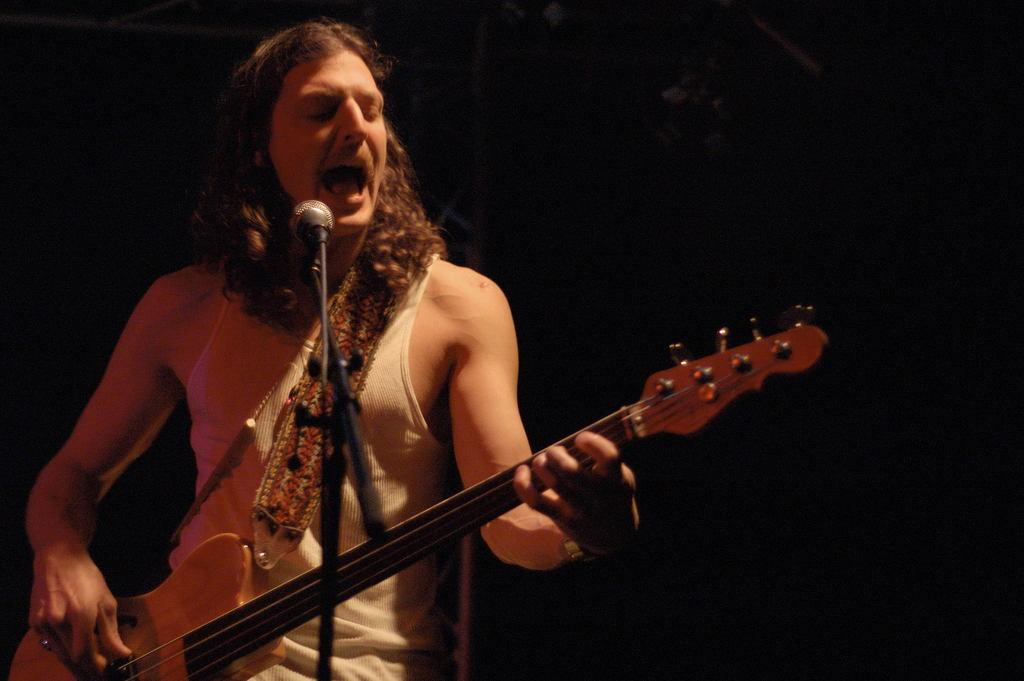What is the main subject of the image? There is a man in the image. What is the man doing in the image? The man is standing, playing a guitar, and singing into a microphone. How many cakes are being served by the man in the image? There are no cakes present in the image; the man is playing a guitar and singing into a microphone. What type of slave is depicted in the image? There is no depiction of a slave in the image; it features a man playing a guitar and singing into a microphone. 